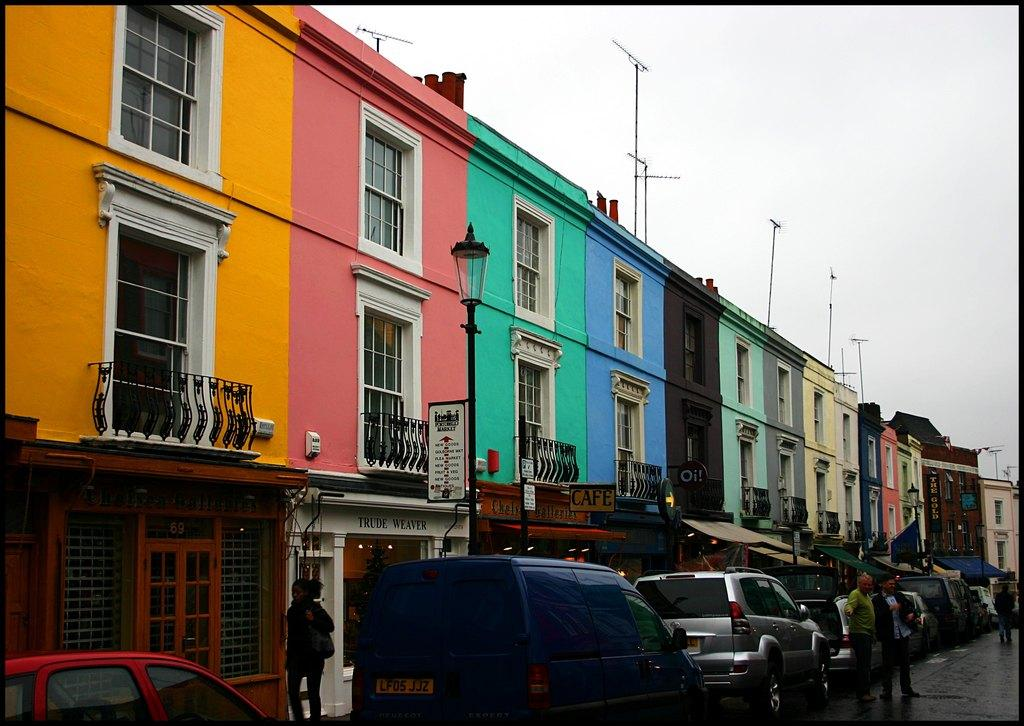What type of buildings can be seen in the image? There are colorful houses in the image. What color are the windows on the houses? The windows on the houses are white. Where are the houses located in relation to the road? The houses are located on the road side. What other establishments can be seen in the image? There are shops visible in the image. How is the road being used in the image? Many cars are parked on the road side. What type of tin is being used to make trouble in the baseball game in the image? There is no tin, trouble, or baseball game present in the image. 